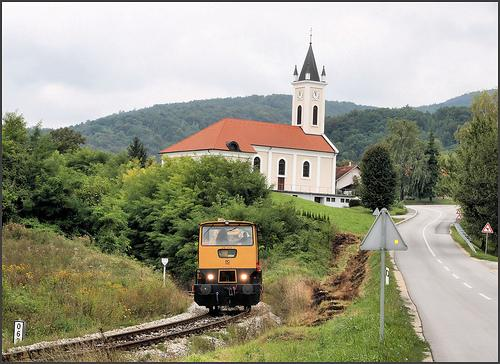Explain the primary purpose of the train in the image. The train is for carrying commuters home and is close to the highway and a church. List the main colors that can be seen in the image. Yellow, green, brown, white, and orange. Give a quick summary of the image, mentioning any prominent features. The image shows a yellow train on railway tracks, near a church and an empty highway, with green trees scattered around. Write a few words about how the image might make someone feel. The image evokes feelings of serenity and calmness as the train moves through the peaceful countryside. Provide a brief description of the central object in the image. A small yellow train is moving through the countryside on railroad tracks. What is the primary mode of transportation shown in the image? The primary mode of transportation is the yellow commuter train on railroad tracks. Mention any interesting details about the church in the image. The church has a brown roof and a white wall with an antennae on top. Describe the setting where the train is located. The train is close to a large church, a road, and surrounded by green trees. Mention any notable specifics of the train in the image. The train is yellow in color and has its headlights on. Tell me about the road in the image. The road is a long, empty, tarmacked highway near the train and church. 